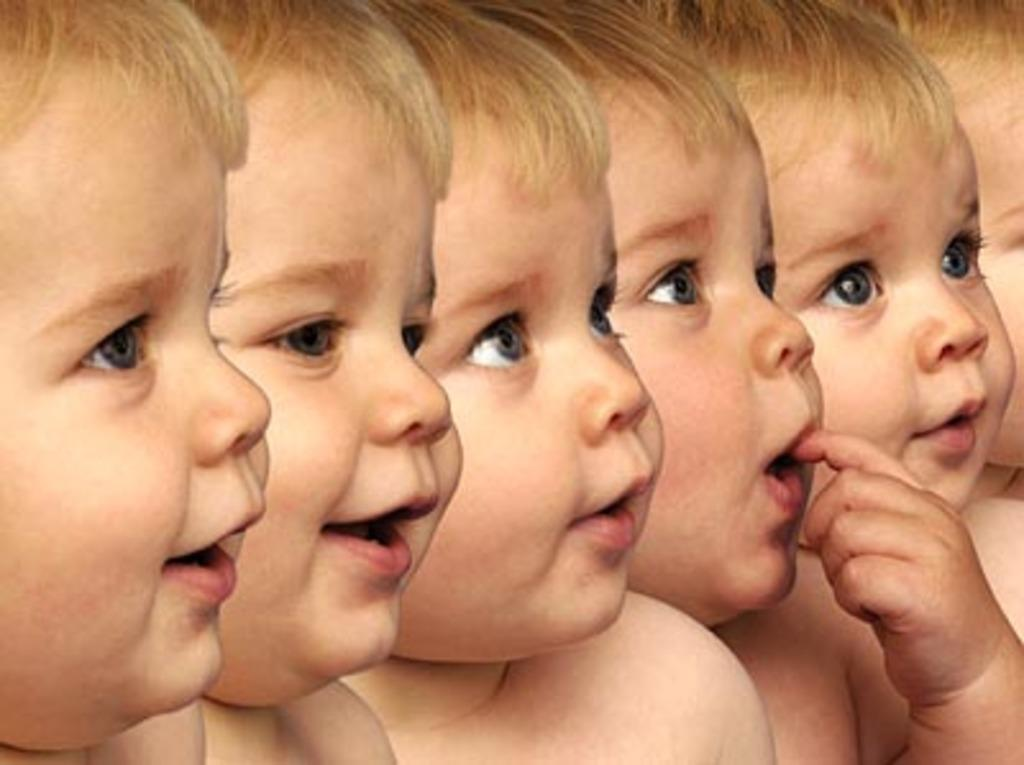What type of editing has been done to the image? The image is edited, but the specific type of editing is not mentioned. What is the main subject of the image? There is a baby in the image. How many facial expressions does the baby have? The baby has different facial expressions. What type of coil is used to support the baby's income in the image? There is no mention of a coil or income in the image, as it features a baby with different facial expressions. 